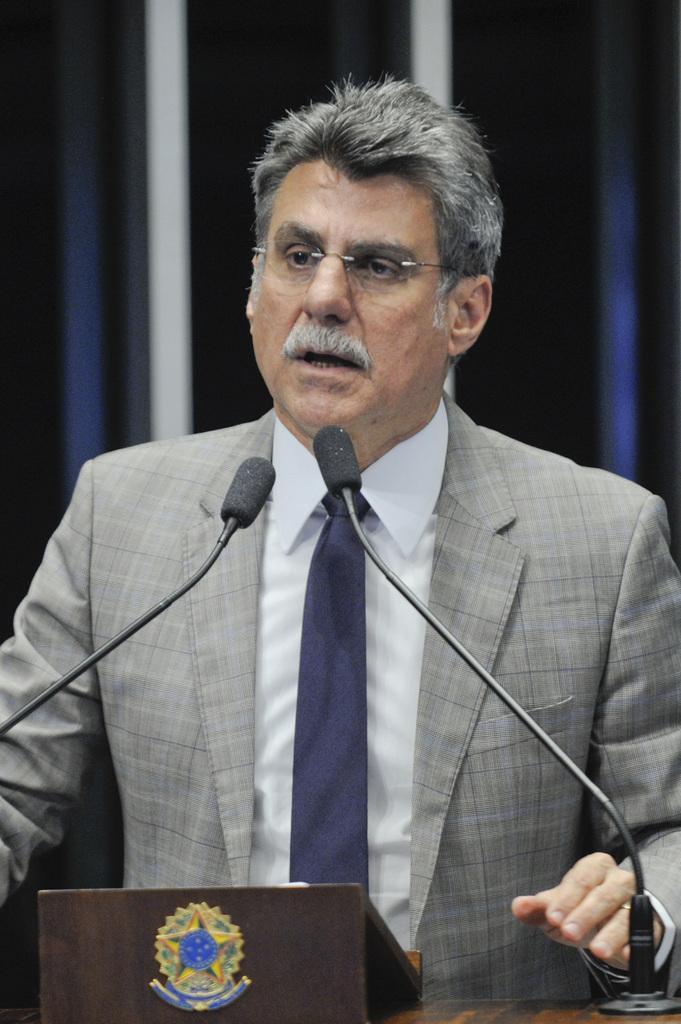How would you summarize this image in a sentence or two? In the picture we can see a person wearing grey color suit standing behind podium on which there are microphones. 